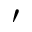Convert formula to latex. <formula><loc_0><loc_0><loc_500><loc_500>^ { \prime }</formula> 